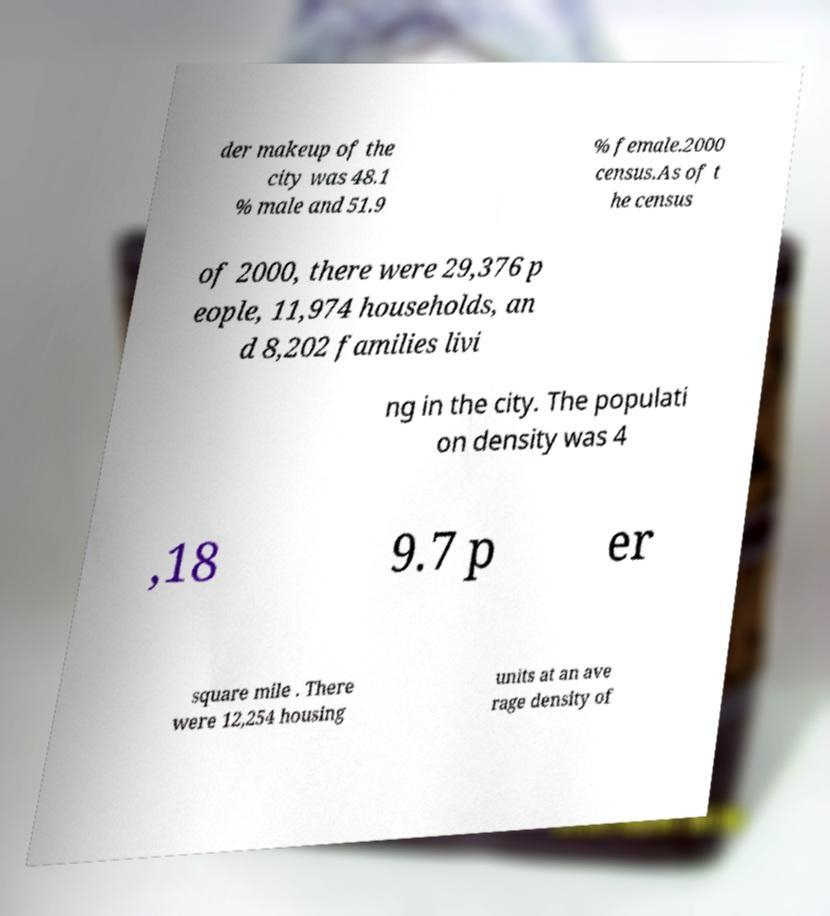Can you read and provide the text displayed in the image?This photo seems to have some interesting text. Can you extract and type it out for me? der makeup of the city was 48.1 % male and 51.9 % female.2000 census.As of t he census of 2000, there were 29,376 p eople, 11,974 households, an d 8,202 families livi ng in the city. The populati on density was 4 ,18 9.7 p er square mile . There were 12,254 housing units at an ave rage density of 